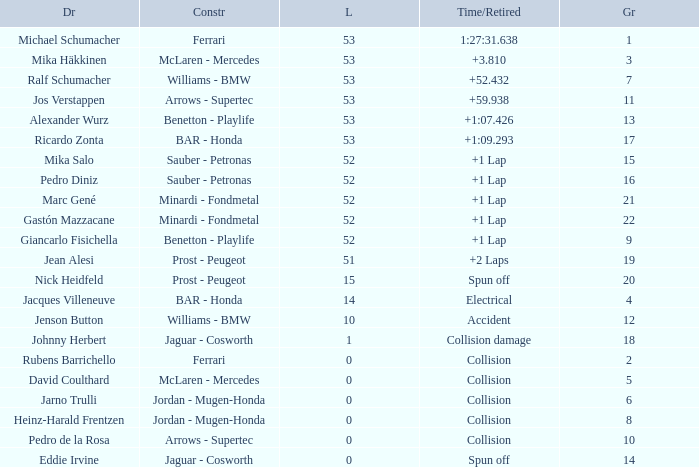What is the name of the driver with a grid less than 14, laps smaller than 53 and a Time/Retired of collision, and a Constructor of ferrari? Rubens Barrichello. 